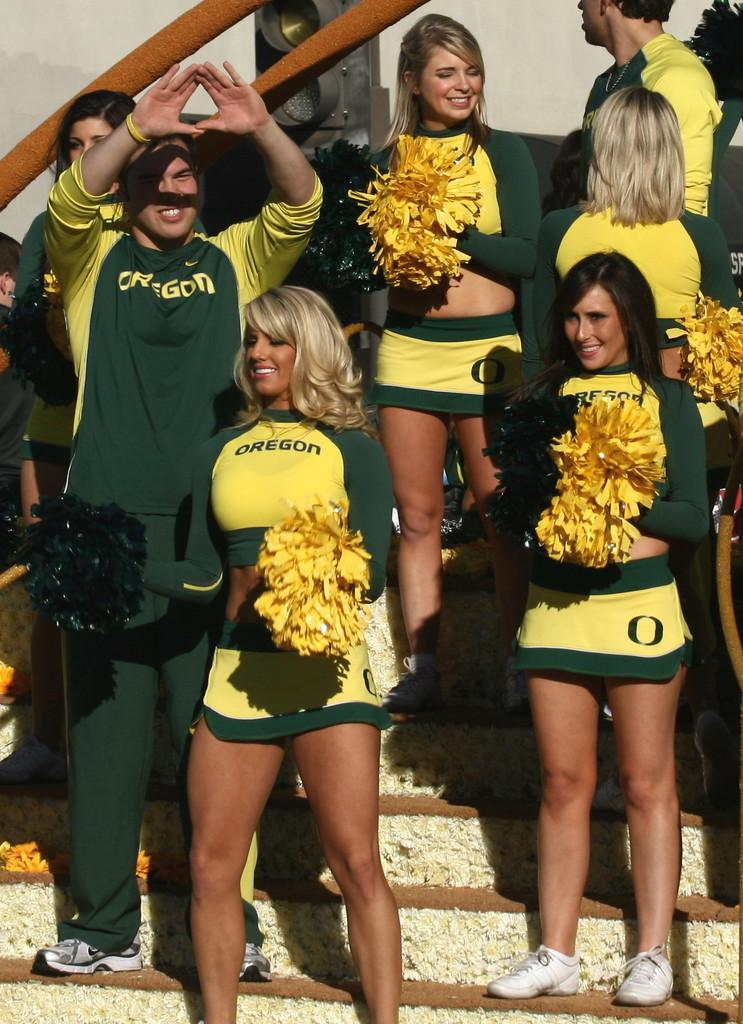<image>
Offer a succinct explanation of the picture presented. Oregon cheerleaders cheer on their team on stop stairs. 